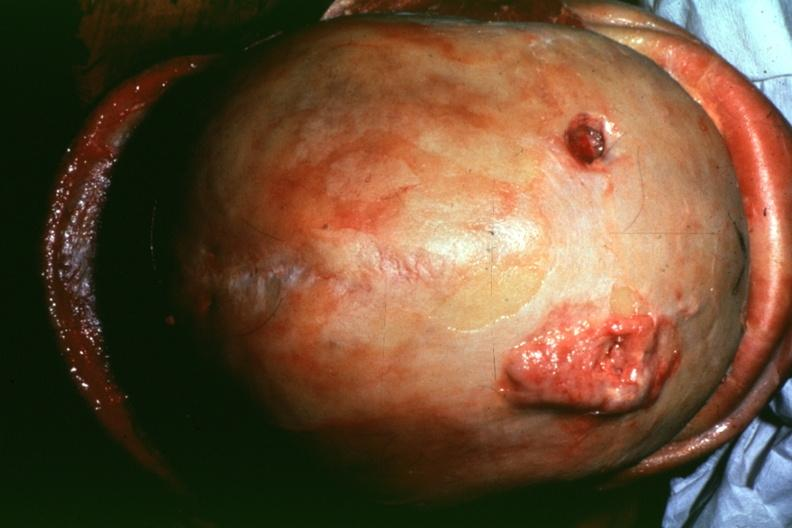s cleft palate present?
Answer the question using a single word or phrase. No 